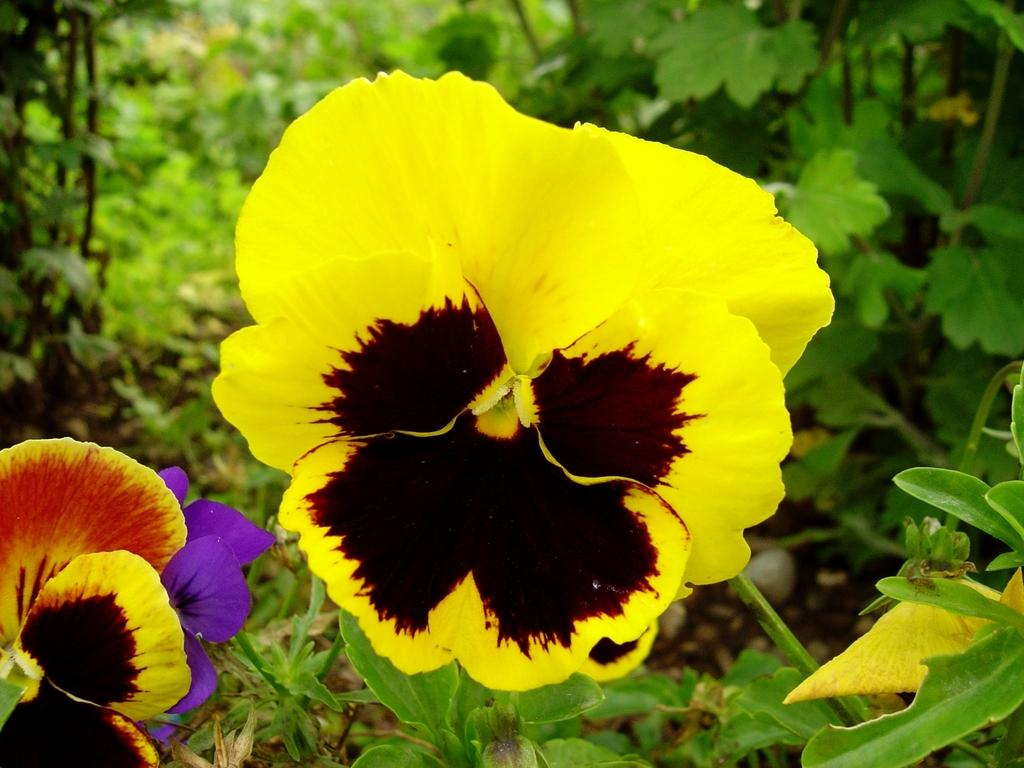What type of flora can be seen in the image? There are flowers in the image. What can be seen in the background of the image? There are plants in the background of the image. Can you see a river flowing through the flowers in the image? There is no river present in the image; it only features flowers and plants. 